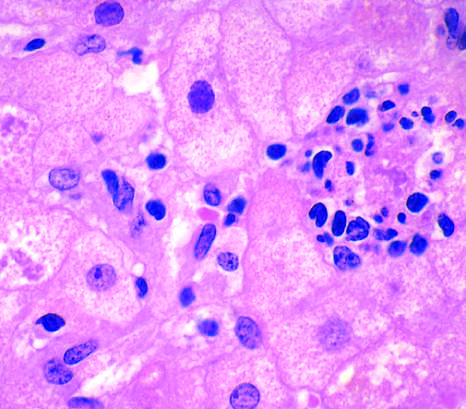what is present in another hepatocyte?
Answer the question using a single word or phrase. A mallory-denk body 